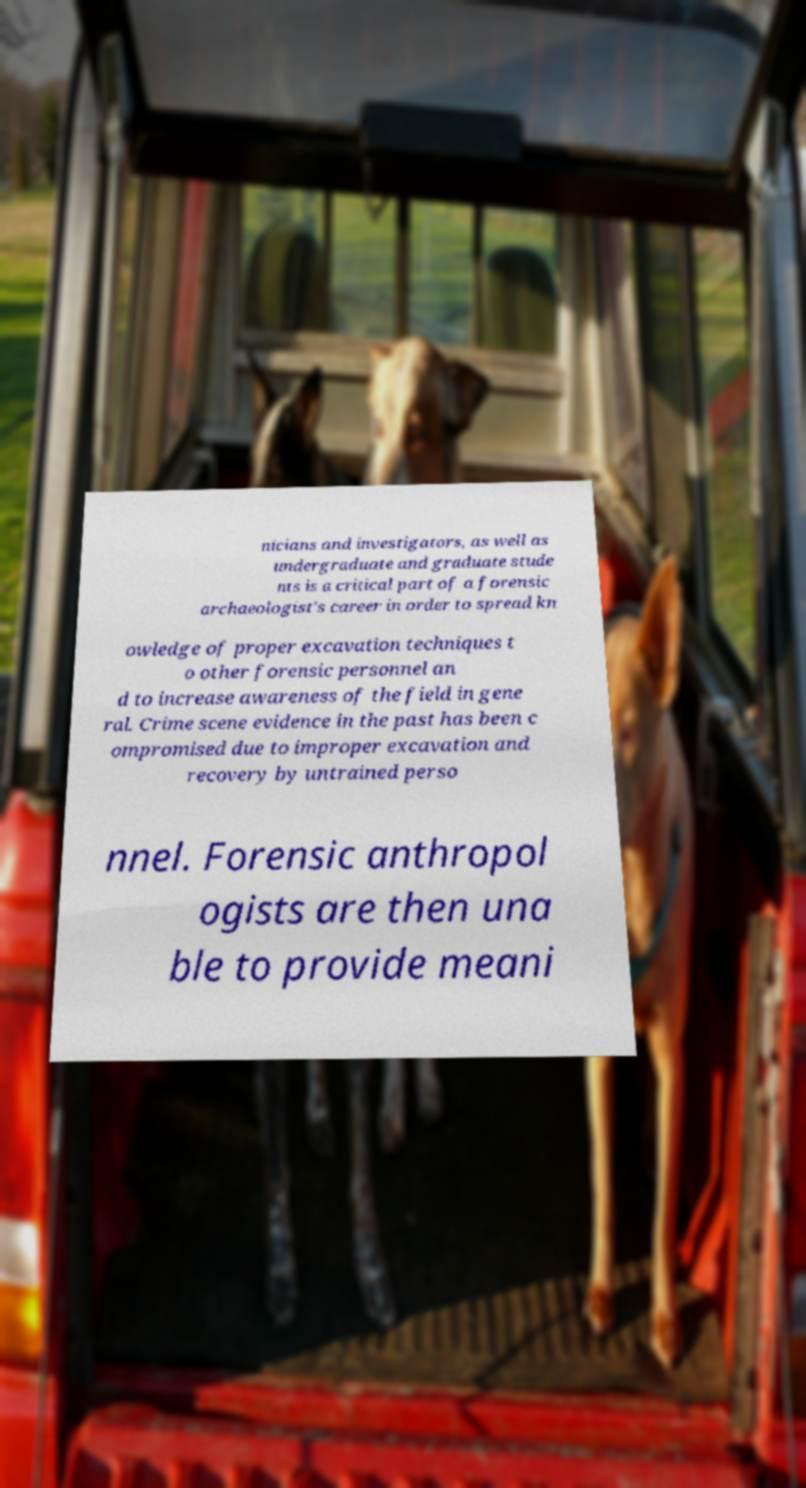What messages or text are displayed in this image? I need them in a readable, typed format. nicians and investigators, as well as undergraduate and graduate stude nts is a critical part of a forensic archaeologist's career in order to spread kn owledge of proper excavation techniques t o other forensic personnel an d to increase awareness of the field in gene ral. Crime scene evidence in the past has been c ompromised due to improper excavation and recovery by untrained perso nnel. Forensic anthropol ogists are then una ble to provide meani 